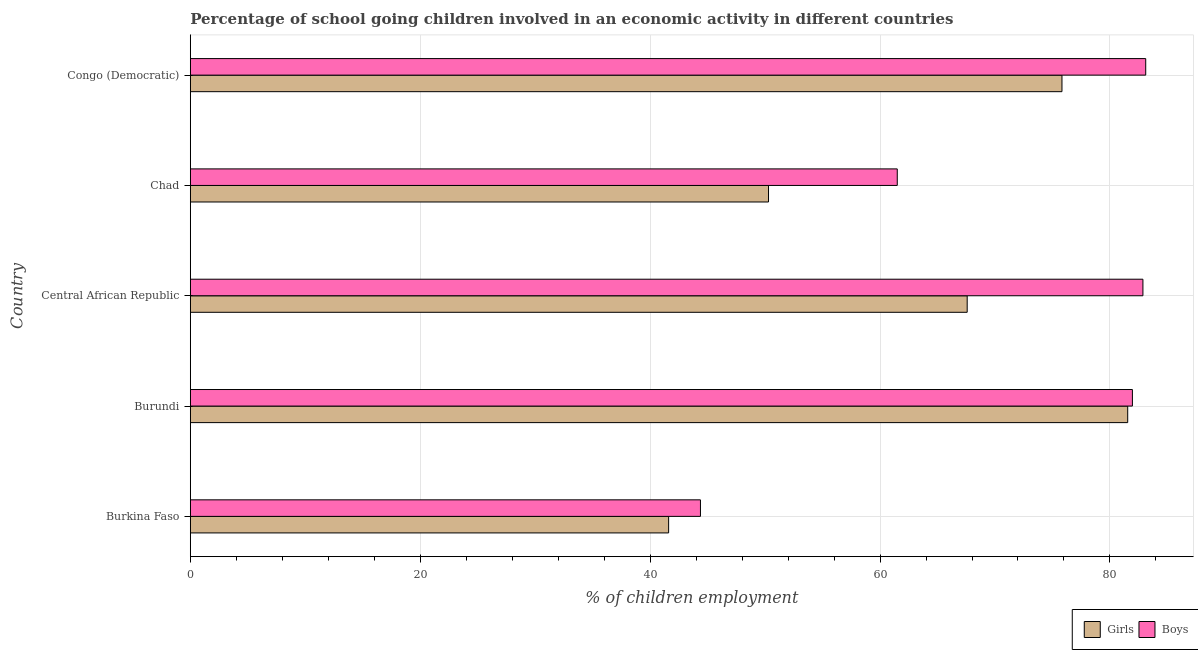How many different coloured bars are there?
Provide a succinct answer. 2. How many groups of bars are there?
Give a very brief answer. 5. Are the number of bars on each tick of the Y-axis equal?
Ensure brevity in your answer.  Yes. What is the label of the 3rd group of bars from the top?
Give a very brief answer. Central African Republic. What is the percentage of school going boys in Chad?
Your response must be concise. 61.5. Across all countries, what is the maximum percentage of school going girls?
Ensure brevity in your answer.  81.54. Across all countries, what is the minimum percentage of school going girls?
Keep it short and to the point. 41.61. In which country was the percentage of school going girls maximum?
Your response must be concise. Burundi. In which country was the percentage of school going boys minimum?
Keep it short and to the point. Burkina Faso. What is the total percentage of school going boys in the graph?
Make the answer very short. 353.81. What is the difference between the percentage of school going boys in Burkina Faso and that in Central African Republic?
Offer a very short reply. -38.49. What is the difference between the percentage of school going boys in Central African Republic and the percentage of school going girls in Congo (Democratic)?
Offer a very short reply. 7.04. What is the average percentage of school going boys per country?
Ensure brevity in your answer.  70.76. What is the difference between the percentage of school going boys and percentage of school going girls in Burkina Faso?
Offer a terse response. 2.77. In how many countries, is the percentage of school going girls greater than 52 %?
Offer a terse response. 3. What is the ratio of the percentage of school going girls in Burundi to that in Central African Republic?
Ensure brevity in your answer.  1.21. Is the percentage of school going boys in Burkina Faso less than that in Burundi?
Make the answer very short. Yes. Is the difference between the percentage of school going girls in Central African Republic and Congo (Democratic) greater than the difference between the percentage of school going boys in Central African Republic and Congo (Democratic)?
Offer a very short reply. No. What is the difference between the highest and the second highest percentage of school going boys?
Ensure brevity in your answer.  0.24. What is the difference between the highest and the lowest percentage of school going girls?
Keep it short and to the point. 39.94. In how many countries, is the percentage of school going girls greater than the average percentage of school going girls taken over all countries?
Make the answer very short. 3. What does the 2nd bar from the top in Central African Republic represents?
Provide a short and direct response. Girls. What does the 2nd bar from the bottom in Central African Republic represents?
Make the answer very short. Boys. Are all the bars in the graph horizontal?
Your answer should be compact. Yes. Does the graph contain any zero values?
Keep it short and to the point. No. How many legend labels are there?
Offer a terse response. 2. How are the legend labels stacked?
Make the answer very short. Horizontal. What is the title of the graph?
Your answer should be compact. Percentage of school going children involved in an economic activity in different countries. Does "National Visitors" appear as one of the legend labels in the graph?
Give a very brief answer. No. What is the label or title of the X-axis?
Offer a very short reply. % of children employment. What is the % of children employment in Girls in Burkina Faso?
Offer a terse response. 41.61. What is the % of children employment of Boys in Burkina Faso?
Give a very brief answer. 44.38. What is the % of children employment of Girls in Burundi?
Make the answer very short. 81.54. What is the % of children employment in Boys in Burundi?
Offer a terse response. 81.96. What is the % of children employment in Girls in Central African Republic?
Give a very brief answer. 67.58. What is the % of children employment of Boys in Central African Republic?
Ensure brevity in your answer.  82.87. What is the % of children employment of Girls in Chad?
Offer a terse response. 50.3. What is the % of children employment of Boys in Chad?
Offer a very short reply. 61.5. What is the % of children employment of Girls in Congo (Democratic)?
Offer a terse response. 75.83. What is the % of children employment in Boys in Congo (Democratic)?
Your answer should be compact. 83.11. Across all countries, what is the maximum % of children employment in Girls?
Your answer should be compact. 81.54. Across all countries, what is the maximum % of children employment of Boys?
Keep it short and to the point. 83.11. Across all countries, what is the minimum % of children employment of Girls?
Keep it short and to the point. 41.61. Across all countries, what is the minimum % of children employment in Boys?
Make the answer very short. 44.38. What is the total % of children employment of Girls in the graph?
Provide a short and direct response. 316.86. What is the total % of children employment of Boys in the graph?
Your answer should be very brief. 353.81. What is the difference between the % of children employment of Girls in Burkina Faso and that in Burundi?
Your answer should be very brief. -39.94. What is the difference between the % of children employment in Boys in Burkina Faso and that in Burundi?
Your response must be concise. -37.58. What is the difference between the % of children employment of Girls in Burkina Faso and that in Central African Republic?
Make the answer very short. -25.97. What is the difference between the % of children employment in Boys in Burkina Faso and that in Central African Republic?
Provide a succinct answer. -38.49. What is the difference between the % of children employment in Girls in Burkina Faso and that in Chad?
Give a very brief answer. -8.69. What is the difference between the % of children employment in Boys in Burkina Faso and that in Chad?
Provide a succinct answer. -17.12. What is the difference between the % of children employment of Girls in Burkina Faso and that in Congo (Democratic)?
Provide a succinct answer. -34.22. What is the difference between the % of children employment in Boys in Burkina Faso and that in Congo (Democratic)?
Provide a short and direct response. -38.73. What is the difference between the % of children employment in Girls in Burundi and that in Central African Republic?
Ensure brevity in your answer.  13.96. What is the difference between the % of children employment in Boys in Burundi and that in Central African Republic?
Your answer should be very brief. -0.91. What is the difference between the % of children employment of Girls in Burundi and that in Chad?
Provide a short and direct response. 31.24. What is the difference between the % of children employment of Boys in Burundi and that in Chad?
Make the answer very short. 20.45. What is the difference between the % of children employment of Girls in Burundi and that in Congo (Democratic)?
Ensure brevity in your answer.  5.72. What is the difference between the % of children employment in Boys in Burundi and that in Congo (Democratic)?
Give a very brief answer. -1.16. What is the difference between the % of children employment in Girls in Central African Republic and that in Chad?
Offer a terse response. 17.28. What is the difference between the % of children employment of Boys in Central African Republic and that in Chad?
Provide a short and direct response. 21.37. What is the difference between the % of children employment of Girls in Central African Republic and that in Congo (Democratic)?
Offer a terse response. -8.25. What is the difference between the % of children employment in Boys in Central African Republic and that in Congo (Democratic)?
Offer a very short reply. -0.24. What is the difference between the % of children employment of Girls in Chad and that in Congo (Democratic)?
Ensure brevity in your answer.  -25.53. What is the difference between the % of children employment in Boys in Chad and that in Congo (Democratic)?
Your response must be concise. -21.61. What is the difference between the % of children employment in Girls in Burkina Faso and the % of children employment in Boys in Burundi?
Keep it short and to the point. -40.35. What is the difference between the % of children employment in Girls in Burkina Faso and the % of children employment in Boys in Central African Republic?
Ensure brevity in your answer.  -41.26. What is the difference between the % of children employment in Girls in Burkina Faso and the % of children employment in Boys in Chad?
Provide a succinct answer. -19.89. What is the difference between the % of children employment of Girls in Burkina Faso and the % of children employment of Boys in Congo (Democratic)?
Make the answer very short. -41.5. What is the difference between the % of children employment in Girls in Burundi and the % of children employment in Boys in Central African Republic?
Make the answer very short. -1.32. What is the difference between the % of children employment in Girls in Burundi and the % of children employment in Boys in Chad?
Ensure brevity in your answer.  20.04. What is the difference between the % of children employment in Girls in Burundi and the % of children employment in Boys in Congo (Democratic)?
Keep it short and to the point. -1.57. What is the difference between the % of children employment in Girls in Central African Republic and the % of children employment in Boys in Chad?
Provide a succinct answer. 6.08. What is the difference between the % of children employment in Girls in Central African Republic and the % of children employment in Boys in Congo (Democratic)?
Keep it short and to the point. -15.53. What is the difference between the % of children employment of Girls in Chad and the % of children employment of Boys in Congo (Democratic)?
Provide a succinct answer. -32.81. What is the average % of children employment of Girls per country?
Give a very brief answer. 63.37. What is the average % of children employment in Boys per country?
Your answer should be compact. 70.76. What is the difference between the % of children employment of Girls and % of children employment of Boys in Burkina Faso?
Provide a short and direct response. -2.77. What is the difference between the % of children employment of Girls and % of children employment of Boys in Burundi?
Your response must be concise. -0.41. What is the difference between the % of children employment in Girls and % of children employment in Boys in Central African Republic?
Give a very brief answer. -15.29. What is the difference between the % of children employment in Girls and % of children employment in Boys in Congo (Democratic)?
Offer a terse response. -7.29. What is the ratio of the % of children employment of Girls in Burkina Faso to that in Burundi?
Keep it short and to the point. 0.51. What is the ratio of the % of children employment of Boys in Burkina Faso to that in Burundi?
Your response must be concise. 0.54. What is the ratio of the % of children employment of Girls in Burkina Faso to that in Central African Republic?
Keep it short and to the point. 0.62. What is the ratio of the % of children employment of Boys in Burkina Faso to that in Central African Republic?
Offer a terse response. 0.54. What is the ratio of the % of children employment of Girls in Burkina Faso to that in Chad?
Make the answer very short. 0.83. What is the ratio of the % of children employment in Boys in Burkina Faso to that in Chad?
Provide a succinct answer. 0.72. What is the ratio of the % of children employment of Girls in Burkina Faso to that in Congo (Democratic)?
Offer a very short reply. 0.55. What is the ratio of the % of children employment of Boys in Burkina Faso to that in Congo (Democratic)?
Keep it short and to the point. 0.53. What is the ratio of the % of children employment in Girls in Burundi to that in Central African Republic?
Give a very brief answer. 1.21. What is the ratio of the % of children employment in Boys in Burundi to that in Central African Republic?
Provide a short and direct response. 0.99. What is the ratio of the % of children employment of Girls in Burundi to that in Chad?
Make the answer very short. 1.62. What is the ratio of the % of children employment in Boys in Burundi to that in Chad?
Your answer should be compact. 1.33. What is the ratio of the % of children employment in Girls in Burundi to that in Congo (Democratic)?
Provide a short and direct response. 1.08. What is the ratio of the % of children employment of Boys in Burundi to that in Congo (Democratic)?
Provide a succinct answer. 0.99. What is the ratio of the % of children employment of Girls in Central African Republic to that in Chad?
Ensure brevity in your answer.  1.34. What is the ratio of the % of children employment of Boys in Central African Republic to that in Chad?
Provide a succinct answer. 1.35. What is the ratio of the % of children employment in Girls in Central African Republic to that in Congo (Democratic)?
Give a very brief answer. 0.89. What is the ratio of the % of children employment in Boys in Central African Republic to that in Congo (Democratic)?
Make the answer very short. 1. What is the ratio of the % of children employment of Girls in Chad to that in Congo (Democratic)?
Make the answer very short. 0.66. What is the ratio of the % of children employment in Boys in Chad to that in Congo (Democratic)?
Make the answer very short. 0.74. What is the difference between the highest and the second highest % of children employment in Girls?
Your response must be concise. 5.72. What is the difference between the highest and the second highest % of children employment in Boys?
Offer a terse response. 0.24. What is the difference between the highest and the lowest % of children employment of Girls?
Your answer should be compact. 39.94. What is the difference between the highest and the lowest % of children employment of Boys?
Your answer should be compact. 38.73. 